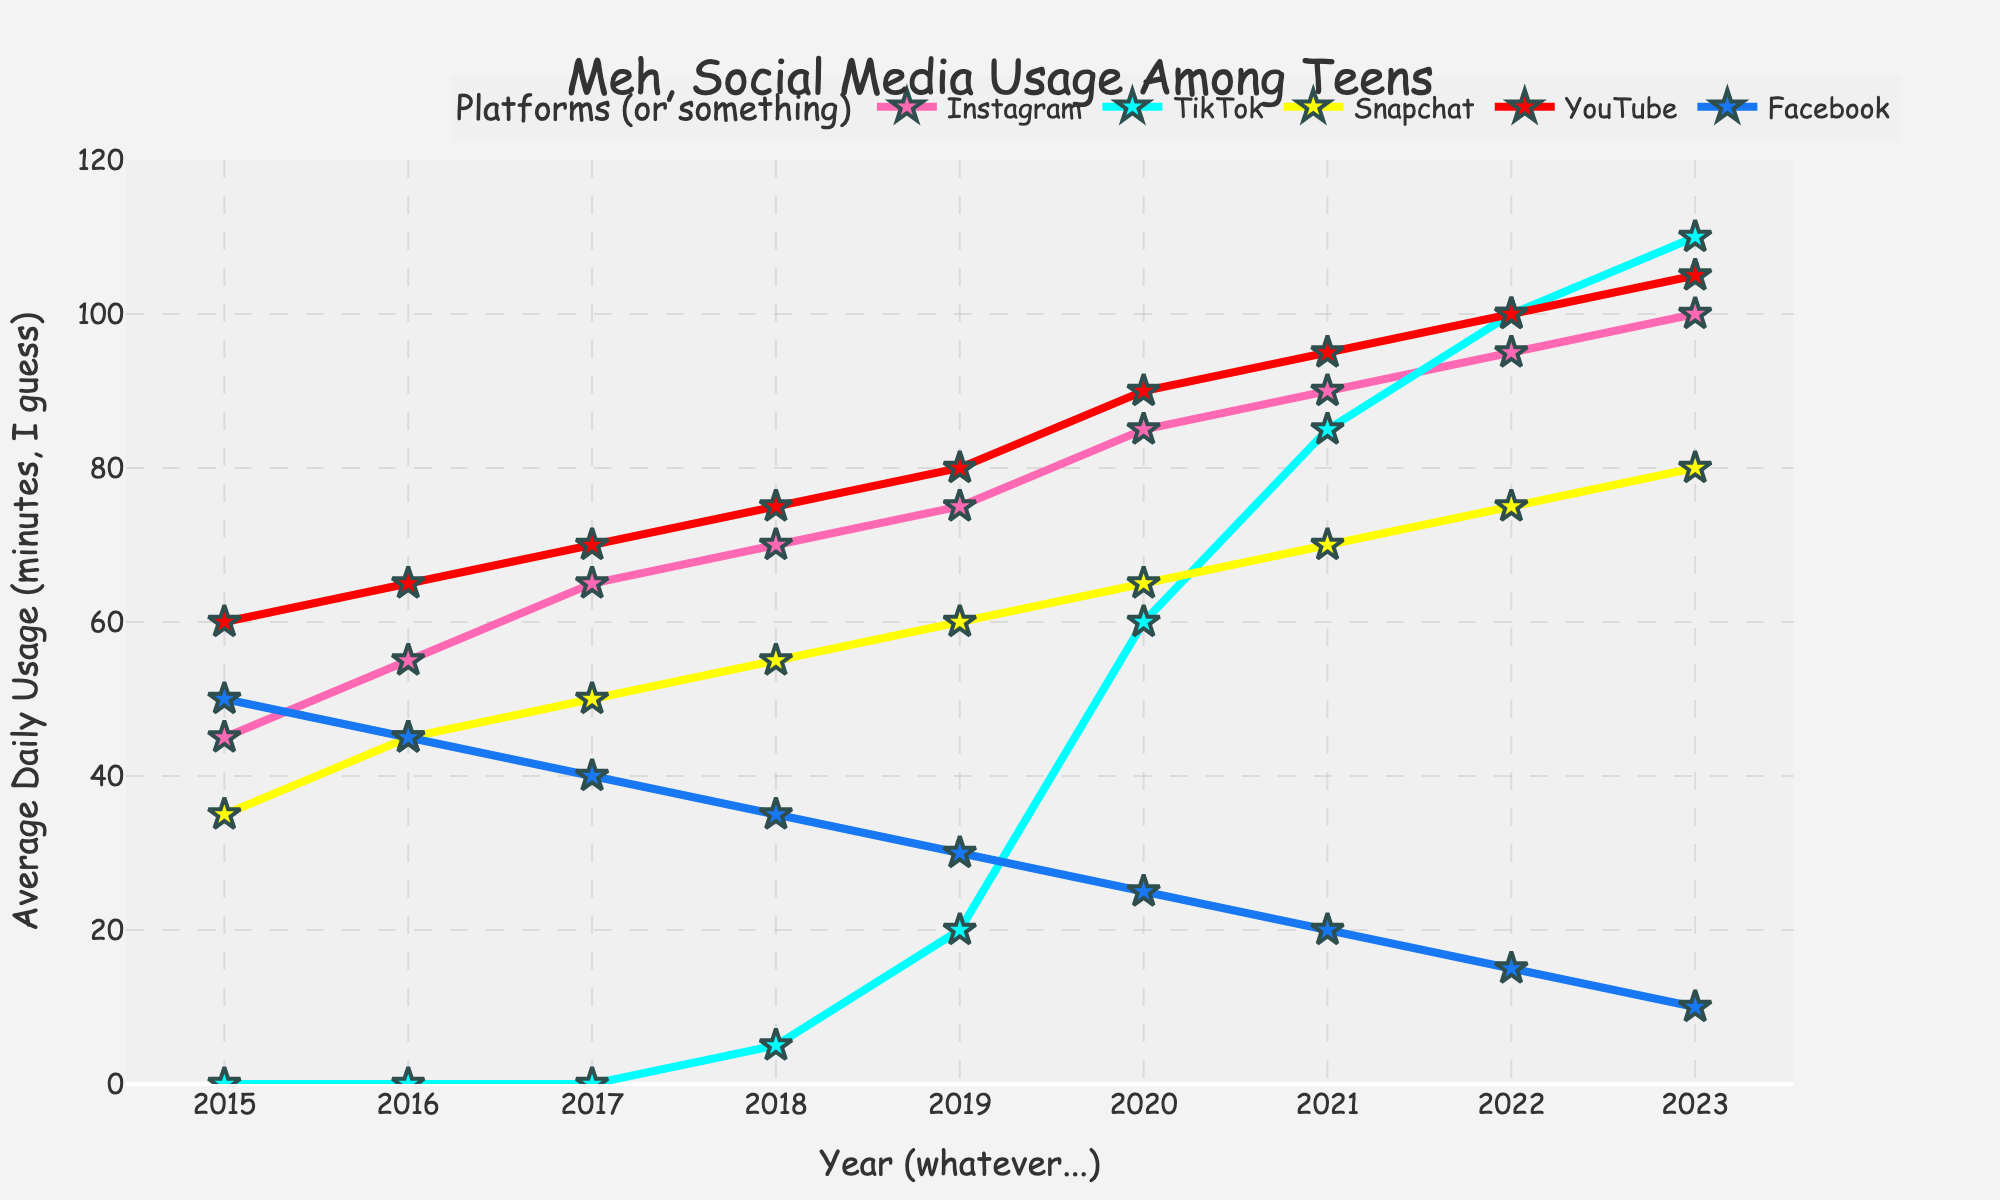What's the average daily usage of Snapchat in 2017? Look at the data point for Snapchat in 2017, which is represented by a yellow line marked "Snapchat". The point at 2017 shows the value 50.
Answer: 50 Which social media platform had the highest average daily usage in 2021? Look at the lines in the plot for 2021. The red line marked "YouTube" reaches the highest value of 95.
Answer: YouTube By how much did the average daily usage of TikTok increase from 2018 to 2020? Check the data points for TikTok in 2018 (5) and 2020 (60). Calculate the increase by subtracting 5 from 60.
Answer: 55 Which two platforms had equal average daily usage in any year, and what was the value? Focus on the points where different platform lines intersect. In 2022, Snapchat and YouTube both have values at 100.
Answer: Snapchat and YouTube, 100 Which platform saw the largest overall increase in average daily usage from 2015 to 2023, and how much was the increase? Observe the span of the lines from 2015 to 2023. TikTok starts from 0 in 2015 and reaches 110 in 2023. Calculate the increase by subtracting 0 from 110.
Answer: TikTok, 110 How did Facebook's average daily usage change over the years? Trace the blue line for Facebook. It starts at 50 in 2015 and steadily decreases each year until it hits 10 in 2023.
Answer: Steadily decreased In which year did Snapchat's average daily usage reach 65 minutes? Follow the yellow line for Snapchat. It reaches 65 in 2020.
Answer: 2020 What is the sum of average daily usage for Instagram and Facebook in 2023? Look at the points for Instagram (100) and Facebook (10) in 2023. Add these two values: 100 + 10.
Answer: 110 Compare the average daily usage of Instagram to YouTube in 2016. Which one had more usage? Check the data points for Instagram (55) and YouTube (65) in 2016. YouTube's 65 is higher.
Answer: YouTube By what percentage did YouTube's average daily usage increase from 2015 to 2023? Find the values for YouTube in 2015 (60) and 2023 (105). Calculate the percentage increase: ((105 - 60) / 60) * 100 = 75%.
Answer: 75% 